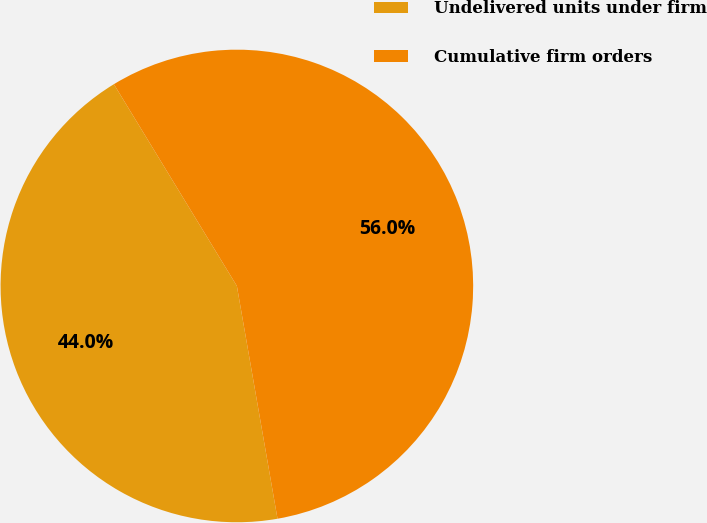Convert chart. <chart><loc_0><loc_0><loc_500><loc_500><pie_chart><fcel>Undelivered units under firm<fcel>Cumulative firm orders<nl><fcel>44.04%<fcel>55.96%<nl></chart> 